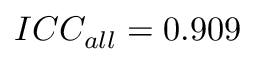Convert formula to latex. <formula><loc_0><loc_0><loc_500><loc_500>I C C _ { a l l } = 0 . 9 0 9</formula> 